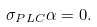<formula> <loc_0><loc_0><loc_500><loc_500>\sigma _ { P L C } \alpha = 0 .</formula> 